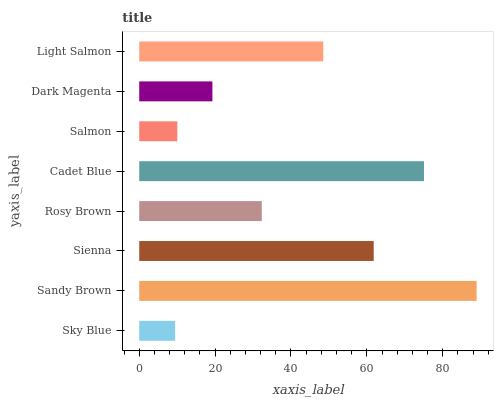Is Sky Blue the minimum?
Answer yes or no. Yes. Is Sandy Brown the maximum?
Answer yes or no. Yes. Is Sienna the minimum?
Answer yes or no. No. Is Sienna the maximum?
Answer yes or no. No. Is Sandy Brown greater than Sienna?
Answer yes or no. Yes. Is Sienna less than Sandy Brown?
Answer yes or no. Yes. Is Sienna greater than Sandy Brown?
Answer yes or no. No. Is Sandy Brown less than Sienna?
Answer yes or no. No. Is Light Salmon the high median?
Answer yes or no. Yes. Is Rosy Brown the low median?
Answer yes or no. Yes. Is Sky Blue the high median?
Answer yes or no. No. Is Sienna the low median?
Answer yes or no. No. 